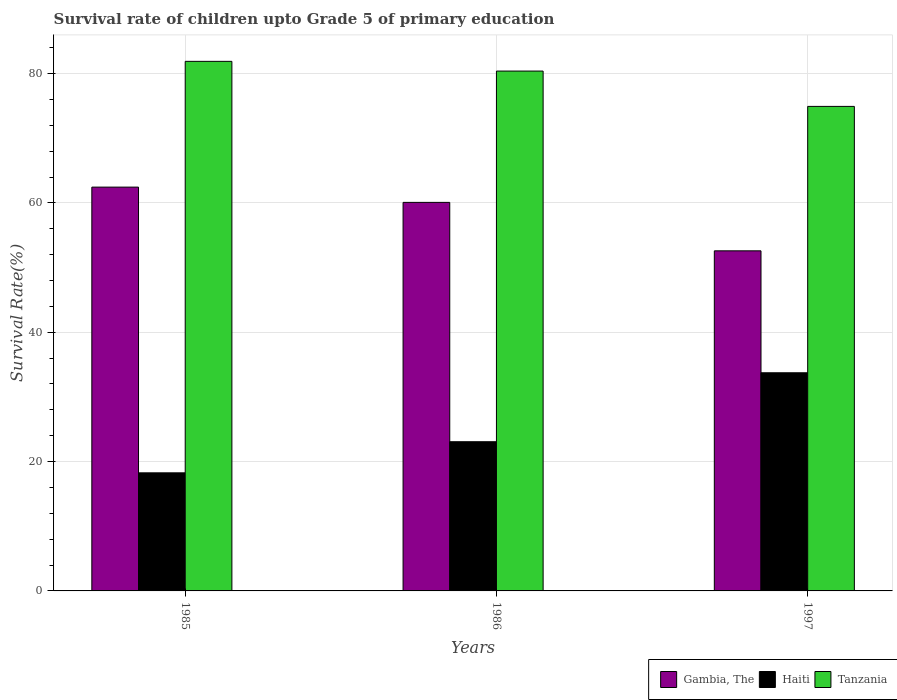How many different coloured bars are there?
Offer a very short reply. 3. How many bars are there on the 1st tick from the left?
Keep it short and to the point. 3. What is the label of the 3rd group of bars from the left?
Your answer should be very brief. 1997. In how many cases, is the number of bars for a given year not equal to the number of legend labels?
Your answer should be very brief. 0. What is the survival rate of children in Haiti in 1997?
Your answer should be very brief. 33.73. Across all years, what is the maximum survival rate of children in Haiti?
Provide a succinct answer. 33.73. Across all years, what is the minimum survival rate of children in Gambia, The?
Offer a very short reply. 52.59. In which year was the survival rate of children in Haiti maximum?
Give a very brief answer. 1997. In which year was the survival rate of children in Haiti minimum?
Keep it short and to the point. 1985. What is the total survival rate of children in Haiti in the graph?
Give a very brief answer. 75.06. What is the difference between the survival rate of children in Haiti in 1986 and that in 1997?
Your response must be concise. -10.66. What is the difference between the survival rate of children in Gambia, The in 1997 and the survival rate of children in Haiti in 1985?
Give a very brief answer. 34.33. What is the average survival rate of children in Haiti per year?
Provide a short and direct response. 25.02. In the year 1997, what is the difference between the survival rate of children in Gambia, The and survival rate of children in Haiti?
Offer a terse response. 18.85. In how many years, is the survival rate of children in Gambia, The greater than 28 %?
Ensure brevity in your answer.  3. What is the ratio of the survival rate of children in Gambia, The in 1986 to that in 1997?
Provide a short and direct response. 1.14. Is the difference between the survival rate of children in Gambia, The in 1985 and 1986 greater than the difference between the survival rate of children in Haiti in 1985 and 1986?
Your answer should be compact. Yes. What is the difference between the highest and the second highest survival rate of children in Haiti?
Offer a very short reply. 10.66. What is the difference between the highest and the lowest survival rate of children in Tanzania?
Offer a very short reply. 6.96. What does the 2nd bar from the left in 1986 represents?
Your response must be concise. Haiti. What does the 3rd bar from the right in 1997 represents?
Offer a very short reply. Gambia, The. Is it the case that in every year, the sum of the survival rate of children in Gambia, The and survival rate of children in Haiti is greater than the survival rate of children in Tanzania?
Provide a short and direct response. No. How many years are there in the graph?
Keep it short and to the point. 3. What is the difference between two consecutive major ticks on the Y-axis?
Give a very brief answer. 20. How many legend labels are there?
Keep it short and to the point. 3. What is the title of the graph?
Make the answer very short. Survival rate of children upto Grade 5 of primary education. Does "Saudi Arabia" appear as one of the legend labels in the graph?
Provide a succinct answer. No. What is the label or title of the X-axis?
Your answer should be very brief. Years. What is the label or title of the Y-axis?
Your answer should be very brief. Survival Rate(%). What is the Survival Rate(%) of Gambia, The in 1985?
Your response must be concise. 62.44. What is the Survival Rate(%) of Haiti in 1985?
Provide a succinct answer. 18.26. What is the Survival Rate(%) in Tanzania in 1985?
Your response must be concise. 81.89. What is the Survival Rate(%) of Gambia, The in 1986?
Your response must be concise. 60.08. What is the Survival Rate(%) of Haiti in 1986?
Keep it short and to the point. 23.07. What is the Survival Rate(%) in Tanzania in 1986?
Your response must be concise. 80.39. What is the Survival Rate(%) in Gambia, The in 1997?
Keep it short and to the point. 52.59. What is the Survival Rate(%) in Haiti in 1997?
Make the answer very short. 33.73. What is the Survival Rate(%) in Tanzania in 1997?
Provide a short and direct response. 74.92. Across all years, what is the maximum Survival Rate(%) in Gambia, The?
Give a very brief answer. 62.44. Across all years, what is the maximum Survival Rate(%) in Haiti?
Give a very brief answer. 33.73. Across all years, what is the maximum Survival Rate(%) in Tanzania?
Give a very brief answer. 81.89. Across all years, what is the minimum Survival Rate(%) of Gambia, The?
Ensure brevity in your answer.  52.59. Across all years, what is the minimum Survival Rate(%) of Haiti?
Your answer should be very brief. 18.26. Across all years, what is the minimum Survival Rate(%) in Tanzania?
Make the answer very short. 74.92. What is the total Survival Rate(%) in Gambia, The in the graph?
Provide a short and direct response. 175.11. What is the total Survival Rate(%) of Haiti in the graph?
Provide a short and direct response. 75.06. What is the total Survival Rate(%) of Tanzania in the graph?
Provide a short and direct response. 237.19. What is the difference between the Survival Rate(%) of Gambia, The in 1985 and that in 1986?
Your answer should be very brief. 2.36. What is the difference between the Survival Rate(%) in Haiti in 1985 and that in 1986?
Provide a short and direct response. -4.81. What is the difference between the Survival Rate(%) in Tanzania in 1985 and that in 1986?
Your answer should be compact. 1.5. What is the difference between the Survival Rate(%) in Gambia, The in 1985 and that in 1997?
Keep it short and to the point. 9.85. What is the difference between the Survival Rate(%) in Haiti in 1985 and that in 1997?
Your answer should be compact. -15.47. What is the difference between the Survival Rate(%) in Tanzania in 1985 and that in 1997?
Your response must be concise. 6.96. What is the difference between the Survival Rate(%) in Gambia, The in 1986 and that in 1997?
Offer a very short reply. 7.49. What is the difference between the Survival Rate(%) of Haiti in 1986 and that in 1997?
Give a very brief answer. -10.66. What is the difference between the Survival Rate(%) in Tanzania in 1986 and that in 1997?
Give a very brief answer. 5.46. What is the difference between the Survival Rate(%) in Gambia, The in 1985 and the Survival Rate(%) in Haiti in 1986?
Offer a very short reply. 39.37. What is the difference between the Survival Rate(%) in Gambia, The in 1985 and the Survival Rate(%) in Tanzania in 1986?
Ensure brevity in your answer.  -17.94. What is the difference between the Survival Rate(%) in Haiti in 1985 and the Survival Rate(%) in Tanzania in 1986?
Your response must be concise. -62.13. What is the difference between the Survival Rate(%) of Gambia, The in 1985 and the Survival Rate(%) of Haiti in 1997?
Ensure brevity in your answer.  28.71. What is the difference between the Survival Rate(%) of Gambia, The in 1985 and the Survival Rate(%) of Tanzania in 1997?
Provide a succinct answer. -12.48. What is the difference between the Survival Rate(%) of Haiti in 1985 and the Survival Rate(%) of Tanzania in 1997?
Offer a terse response. -56.66. What is the difference between the Survival Rate(%) of Gambia, The in 1986 and the Survival Rate(%) of Haiti in 1997?
Offer a terse response. 26.35. What is the difference between the Survival Rate(%) in Gambia, The in 1986 and the Survival Rate(%) in Tanzania in 1997?
Offer a terse response. -14.84. What is the difference between the Survival Rate(%) of Haiti in 1986 and the Survival Rate(%) of Tanzania in 1997?
Ensure brevity in your answer.  -51.85. What is the average Survival Rate(%) in Gambia, The per year?
Provide a short and direct response. 58.37. What is the average Survival Rate(%) of Haiti per year?
Keep it short and to the point. 25.02. What is the average Survival Rate(%) of Tanzania per year?
Offer a very short reply. 79.06. In the year 1985, what is the difference between the Survival Rate(%) in Gambia, The and Survival Rate(%) in Haiti?
Your response must be concise. 44.18. In the year 1985, what is the difference between the Survival Rate(%) in Gambia, The and Survival Rate(%) in Tanzania?
Make the answer very short. -19.45. In the year 1985, what is the difference between the Survival Rate(%) in Haiti and Survival Rate(%) in Tanzania?
Provide a short and direct response. -63.63. In the year 1986, what is the difference between the Survival Rate(%) in Gambia, The and Survival Rate(%) in Haiti?
Your answer should be compact. 37.01. In the year 1986, what is the difference between the Survival Rate(%) of Gambia, The and Survival Rate(%) of Tanzania?
Provide a succinct answer. -20.31. In the year 1986, what is the difference between the Survival Rate(%) in Haiti and Survival Rate(%) in Tanzania?
Offer a very short reply. -57.32. In the year 1997, what is the difference between the Survival Rate(%) in Gambia, The and Survival Rate(%) in Haiti?
Offer a very short reply. 18.86. In the year 1997, what is the difference between the Survival Rate(%) of Gambia, The and Survival Rate(%) of Tanzania?
Keep it short and to the point. -22.34. In the year 1997, what is the difference between the Survival Rate(%) of Haiti and Survival Rate(%) of Tanzania?
Provide a succinct answer. -41.19. What is the ratio of the Survival Rate(%) in Gambia, The in 1985 to that in 1986?
Offer a terse response. 1.04. What is the ratio of the Survival Rate(%) in Haiti in 1985 to that in 1986?
Offer a very short reply. 0.79. What is the ratio of the Survival Rate(%) of Tanzania in 1985 to that in 1986?
Offer a very short reply. 1.02. What is the ratio of the Survival Rate(%) in Gambia, The in 1985 to that in 1997?
Offer a terse response. 1.19. What is the ratio of the Survival Rate(%) in Haiti in 1985 to that in 1997?
Your response must be concise. 0.54. What is the ratio of the Survival Rate(%) of Tanzania in 1985 to that in 1997?
Offer a terse response. 1.09. What is the ratio of the Survival Rate(%) of Gambia, The in 1986 to that in 1997?
Offer a very short reply. 1.14. What is the ratio of the Survival Rate(%) of Haiti in 1986 to that in 1997?
Offer a very short reply. 0.68. What is the ratio of the Survival Rate(%) in Tanzania in 1986 to that in 1997?
Your answer should be compact. 1.07. What is the difference between the highest and the second highest Survival Rate(%) of Gambia, The?
Ensure brevity in your answer.  2.36. What is the difference between the highest and the second highest Survival Rate(%) in Haiti?
Keep it short and to the point. 10.66. What is the difference between the highest and the second highest Survival Rate(%) of Tanzania?
Keep it short and to the point. 1.5. What is the difference between the highest and the lowest Survival Rate(%) in Gambia, The?
Offer a very short reply. 9.85. What is the difference between the highest and the lowest Survival Rate(%) of Haiti?
Ensure brevity in your answer.  15.47. What is the difference between the highest and the lowest Survival Rate(%) in Tanzania?
Give a very brief answer. 6.96. 